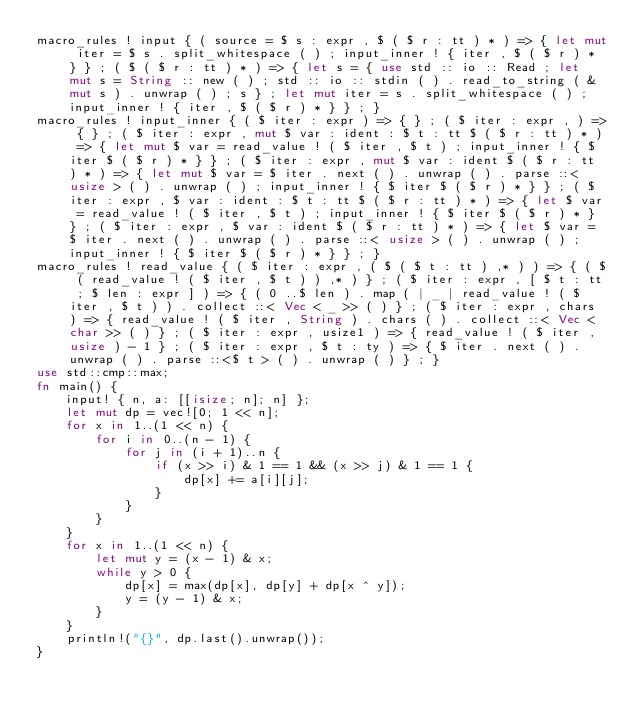Convert code to text. <code><loc_0><loc_0><loc_500><loc_500><_Rust_>macro_rules ! input { ( source = $ s : expr , $ ( $ r : tt ) * ) => { let mut iter = $ s . split_whitespace ( ) ; input_inner ! { iter , $ ( $ r ) * } } ; ( $ ( $ r : tt ) * ) => { let s = { use std :: io :: Read ; let mut s = String :: new ( ) ; std :: io :: stdin ( ) . read_to_string ( & mut s ) . unwrap ( ) ; s } ; let mut iter = s . split_whitespace ( ) ; input_inner ! { iter , $ ( $ r ) * } } ; }
macro_rules ! input_inner { ( $ iter : expr ) => { } ; ( $ iter : expr , ) => { } ; ( $ iter : expr , mut $ var : ident : $ t : tt $ ( $ r : tt ) * ) => { let mut $ var = read_value ! ( $ iter , $ t ) ; input_inner ! { $ iter $ ( $ r ) * } } ; ( $ iter : expr , mut $ var : ident $ ( $ r : tt ) * ) => { let mut $ var = $ iter . next ( ) . unwrap ( ) . parse ::< usize > ( ) . unwrap ( ) ; input_inner ! { $ iter $ ( $ r ) * } } ; ( $ iter : expr , $ var : ident : $ t : tt $ ( $ r : tt ) * ) => { let $ var = read_value ! ( $ iter , $ t ) ; input_inner ! { $ iter $ ( $ r ) * } } ; ( $ iter : expr , $ var : ident $ ( $ r : tt ) * ) => { let $ var = $ iter . next ( ) . unwrap ( ) . parse ::< usize > ( ) . unwrap ( ) ; input_inner ! { $ iter $ ( $ r ) * } } ; }
macro_rules ! read_value { ( $ iter : expr , ( $ ( $ t : tt ) ,* ) ) => { ( $ ( read_value ! ( $ iter , $ t ) ) ,* ) } ; ( $ iter : expr , [ $ t : tt ; $ len : expr ] ) => { ( 0 ..$ len ) . map ( | _ | read_value ! ( $ iter , $ t ) ) . collect ::< Vec < _ >> ( ) } ; ( $ iter : expr , chars ) => { read_value ! ( $ iter , String ) . chars ( ) . collect ::< Vec < char >> ( ) } ; ( $ iter : expr , usize1 ) => { read_value ! ( $ iter , usize ) - 1 } ; ( $ iter : expr , $ t : ty ) => { $ iter . next ( ) . unwrap ( ) . parse ::<$ t > ( ) . unwrap ( ) } ; }
use std::cmp::max;
fn main() {
    input! { n, a: [[isize; n]; n] };
    let mut dp = vec![0; 1 << n];
    for x in 1..(1 << n) {
        for i in 0..(n - 1) {
            for j in (i + 1)..n {
                if (x >> i) & 1 == 1 && (x >> j) & 1 == 1 {
                    dp[x] += a[i][j];
                }
            }
        }
    }
    for x in 1..(1 << n) {
        let mut y = (x - 1) & x;
        while y > 0 {
            dp[x] = max(dp[x], dp[y] + dp[x ^ y]);
            y = (y - 1) & x;
        }
    }
    println!("{}", dp.last().unwrap());
}
</code> 